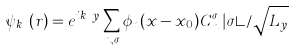<formula> <loc_0><loc_0><loc_500><loc_500>\psi _ { k _ { y } } ( { r } ) = e ^ { i k _ { y } y } \sum _ { n , \sigma } \phi _ { n } ( x - x _ { 0 } ) C ^ { \sigma } _ { n } \, | \sigma \rangle / \sqrt { L _ { y } }</formula> 